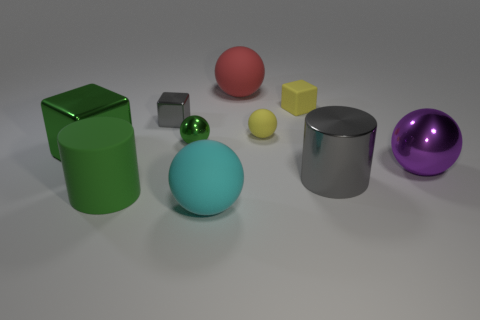What number of things are either tiny spheres or large gray metallic cylinders that are in front of the small yellow block?
Offer a terse response. 3. Are there any yellow things of the same size as the green metallic sphere?
Ensure brevity in your answer.  Yes. Is the big cyan thing made of the same material as the big cube?
Offer a very short reply. No. How many objects are either gray metallic things or big cyan rubber objects?
Make the answer very short. 3. The metallic cylinder is what size?
Keep it short and to the point. Large. Are there fewer large cyan spheres than small purple matte cylinders?
Offer a very short reply. No. What number of metallic balls are the same color as the tiny matte sphere?
Give a very brief answer. 0. There is a metallic thing in front of the purple thing; is it the same color as the large shiny ball?
Give a very brief answer. No. What is the shape of the large metal object left of the large cyan object?
Your answer should be compact. Cube. There is a cylinder to the left of the big cyan ball; is there a green matte cylinder behind it?
Give a very brief answer. No. 